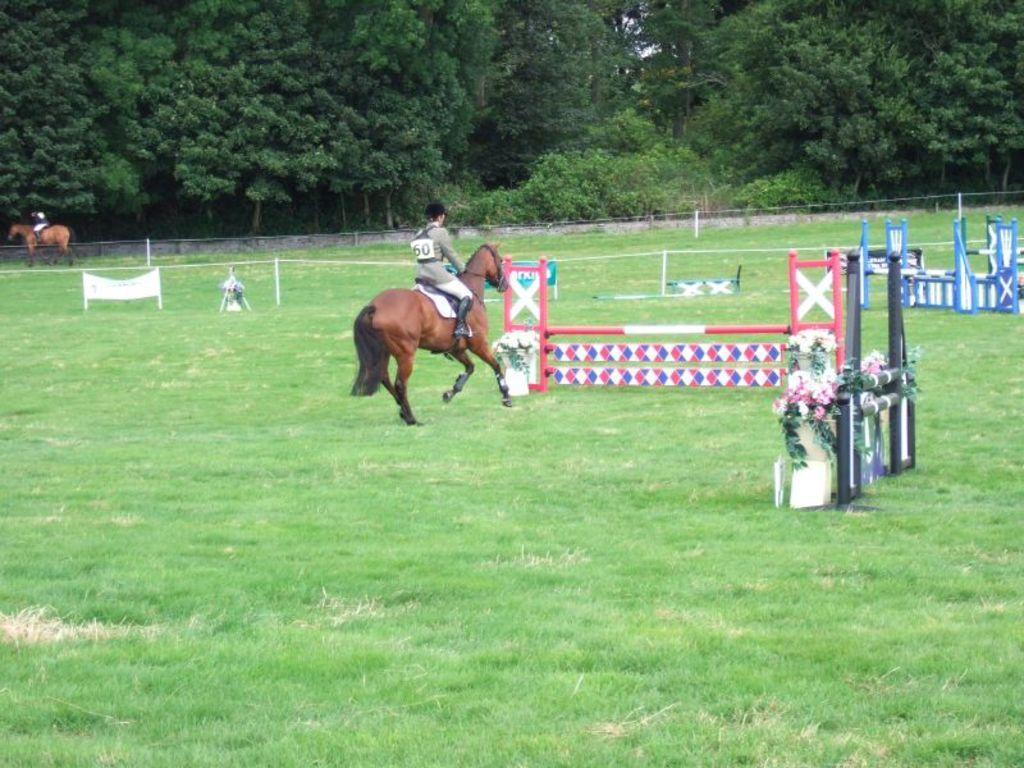How many people are in the image? There are two people in the image. What are the people doing in the image? The people are sitting on horses. What type of vegetation can be seen in the image? There are flowers, grass, and trees visible in the image. What else can be seen on the ground in the image? There are other objects on the ground in the image. Where is the kitten playing with a brush in the image? There is no kitten or brush present in the image. What type of thing is the kitten using to play with the brush in the image? Since there is no kitten or brush in the image, it is not possible to determine what type of thing the kitten might be using to play with the brush. 